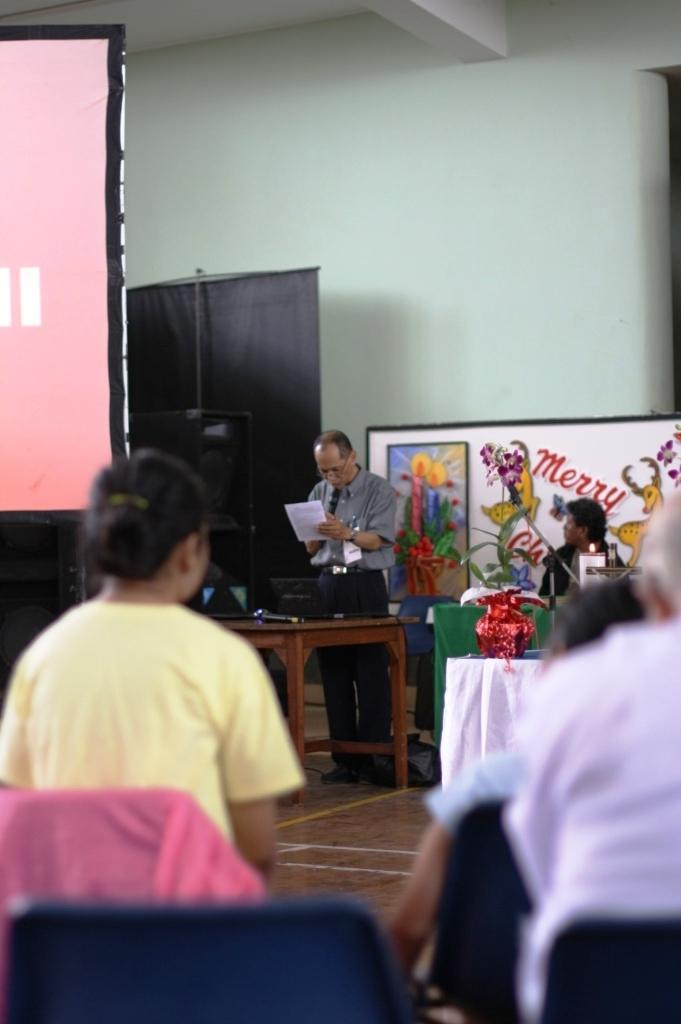What is the main object in the image? There is a screen in the image. What is the person standing and reading doing? The person is reading a paper. What piece of furniture is present in the image? There is a table in the image. What is the position of the second person in the image? The second person is sitting on a chair. What can be seen in the background of the image? There is a wall in the background of the image. What type of cushion is being used for the argument in the image? There is no cushion or argument present in the image. Can you tell me how many caves are visible in the image? There are no caves visible in the image. 